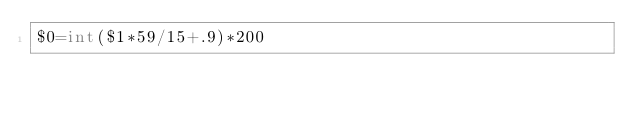<code> <loc_0><loc_0><loc_500><loc_500><_Awk_>$0=int($1*59/15+.9)*200</code> 